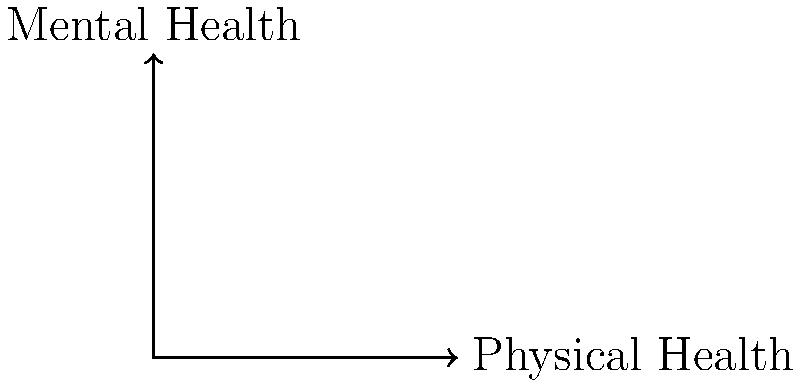Given the vector representation of overall health status projected onto axes of physical and mental well-being, what is the magnitude of the overall health vector? Round your answer to one decimal place. To find the magnitude of the overall health vector, we need to follow these steps:

1. Identify the components of the vector:
   Physical health (x-component): 7.0
   Mental health (y-component): 4.0

2. Use the Pythagorean theorem to calculate the magnitude:
   Magnitude = $\sqrt{x^2 + y^2}$

3. Substitute the values:
   Magnitude = $\sqrt{7.0^2 + 4.0^2}$

4. Calculate:
   Magnitude = $\sqrt{49 + 16}$
   Magnitude = $\sqrt{65}$

5. Evaluate and round to one decimal place:
   Magnitude ≈ 8.1

The magnitude of the overall health vector represents the combined measure of physical and mental well-being on a scale from 0 to 10, where 10 would indicate perfect health in both dimensions.
Answer: 8.1 